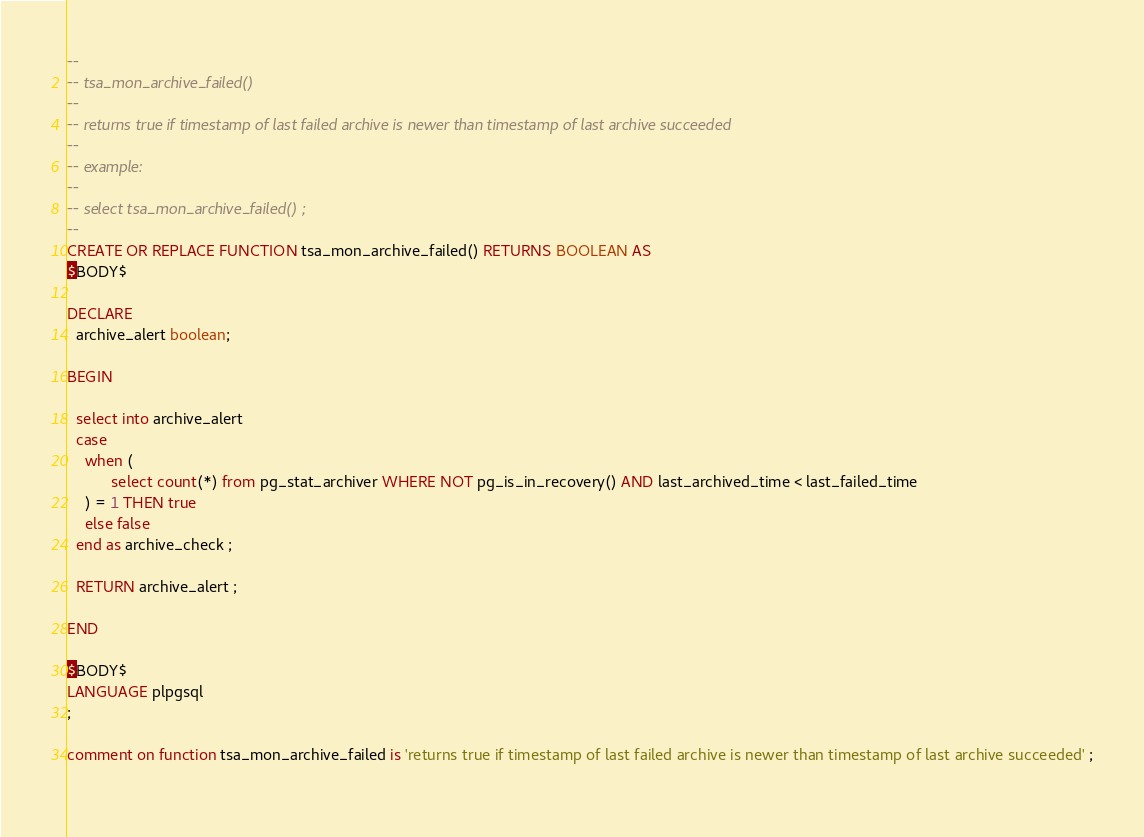<code> <loc_0><loc_0><loc_500><loc_500><_SQL_>--
-- tsa_mon_archive_failed()
--
-- returns true if timestamp of last failed archive is newer than timestamp of last archive succeeded 
--
-- example: 
-- 
-- select tsa_mon_archive_failed() ; 
--
CREATE OR REPLACE FUNCTION tsa_mon_archive_failed() RETURNS BOOLEAN AS
$BODY$

DECLARE  
  archive_alert boolean;

BEGIN

  select into archive_alert
  case 
    when ( 
          select count(*) from pg_stat_archiver WHERE NOT pg_is_in_recovery() AND last_archived_time < last_failed_time
    ) = 1 THEN true
    else false
  end as archive_check ;
  
  RETURN archive_alert ;

END

$BODY$
LANGUAGE plpgsql
;

comment on function tsa_mon_archive_failed is 'returns true if timestamp of last failed archive is newer than timestamp of last archive succeeded' ;
   </code> 